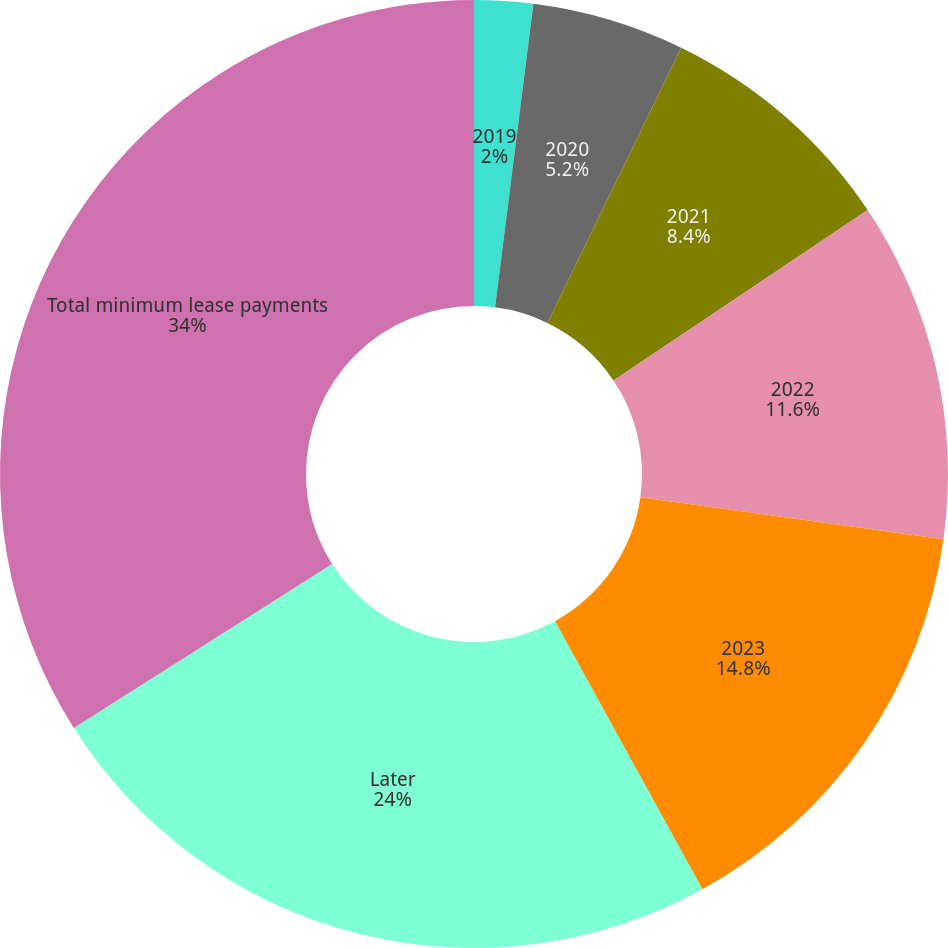Convert chart. <chart><loc_0><loc_0><loc_500><loc_500><pie_chart><fcel>2019<fcel>2020<fcel>2021<fcel>2022<fcel>2023<fcel>Later<fcel>Total minimum lease payments<nl><fcel>2.0%<fcel>5.2%<fcel>8.4%<fcel>11.6%<fcel>14.8%<fcel>24.0%<fcel>34.0%<nl></chart> 